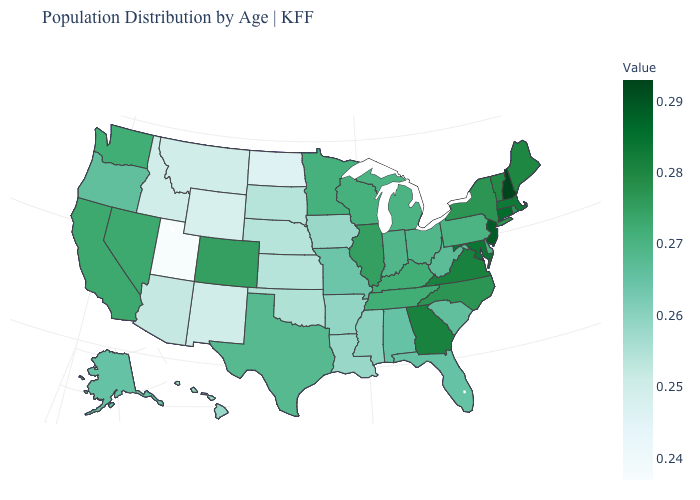Is the legend a continuous bar?
Quick response, please. Yes. Is the legend a continuous bar?
Write a very short answer. Yes. Does Minnesota have the highest value in the MidWest?
Answer briefly. No. 